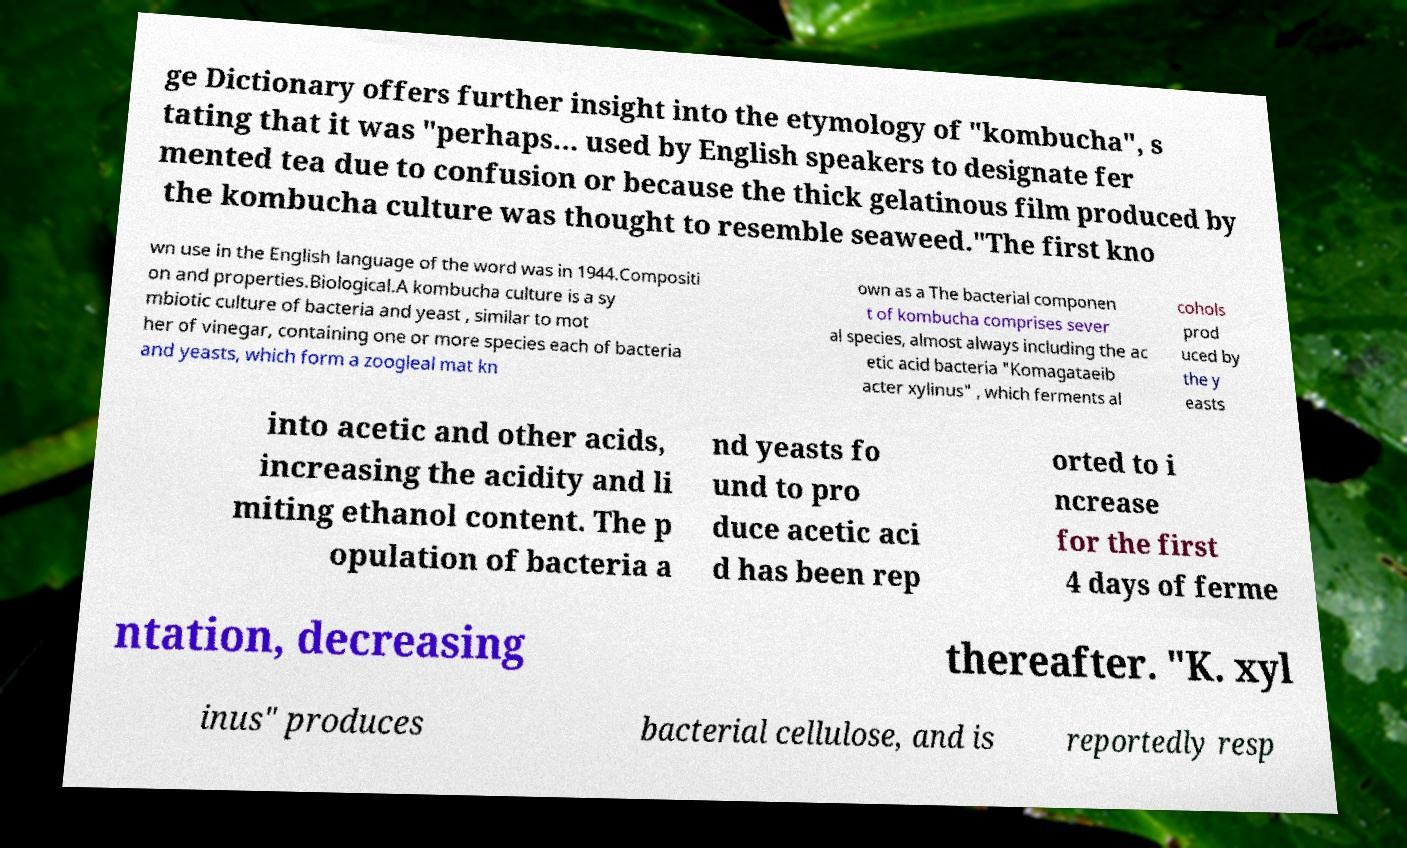For documentation purposes, I need the text within this image transcribed. Could you provide that? ge Dictionary offers further insight into the etymology of "kombucha", s tating that it was "perhaps... used by English speakers to designate fer mented tea due to confusion or because the thick gelatinous film produced by the kombucha culture was thought to resemble seaweed."The first kno wn use in the English language of the word was in 1944.Compositi on and properties.Biological.A kombucha culture is a sy mbiotic culture of bacteria and yeast , similar to mot her of vinegar, containing one or more species each of bacteria and yeasts, which form a zoogleal mat kn own as a The bacterial componen t of kombucha comprises sever al species, almost always including the ac etic acid bacteria "Komagataeib acter xylinus" , which ferments al cohols prod uced by the y easts into acetic and other acids, increasing the acidity and li miting ethanol content. The p opulation of bacteria a nd yeasts fo und to pro duce acetic aci d has been rep orted to i ncrease for the first 4 days of ferme ntation, decreasing thereafter. "K. xyl inus" produces bacterial cellulose, and is reportedly resp 